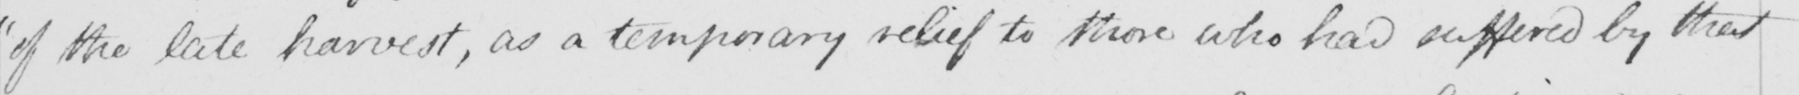Can you read and transcribe this handwriting? of the late harvest , as a temporary relief to those who had suffered by that 